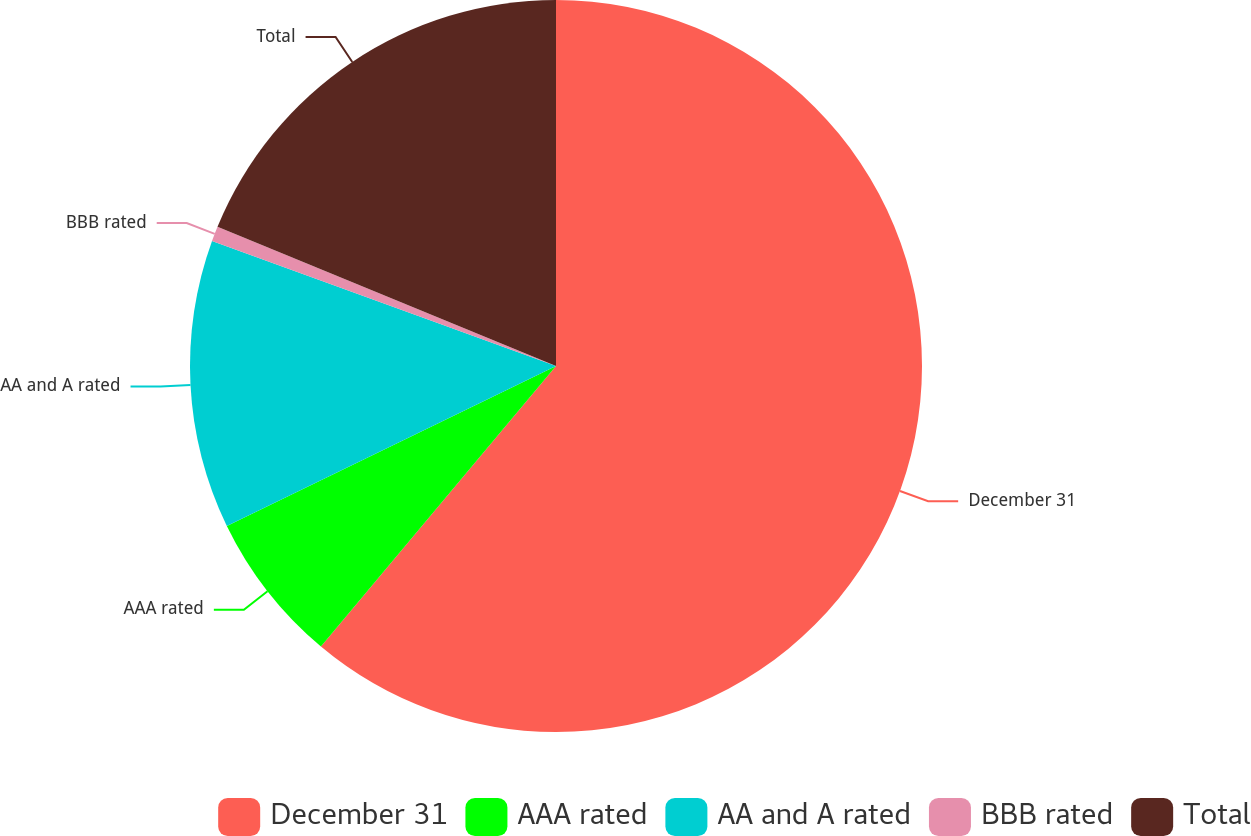Convert chart to OTSL. <chart><loc_0><loc_0><loc_500><loc_500><pie_chart><fcel>December 31<fcel>AAA rated<fcel>AA and A rated<fcel>BBB rated<fcel>Total<nl><fcel>61.1%<fcel>6.7%<fcel>12.75%<fcel>0.66%<fcel>18.79%<nl></chart> 